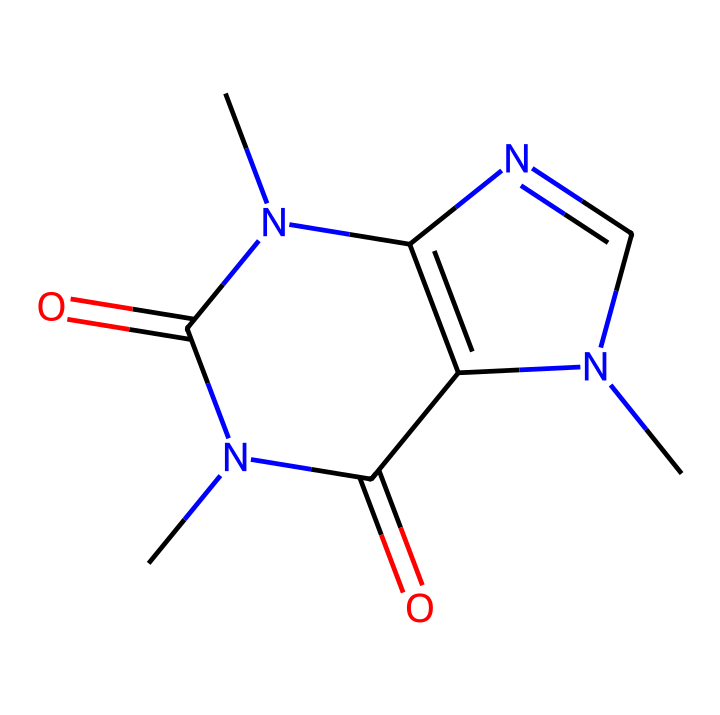What is the molecular formula of caffeine? To determine the molecular formula, we analyze the chemical structure. The SMILES representation indicates there are 8 carbons, 10 hydrogens, 4 nitrogens, and 2 oxygens. By counting, we find the formula is C8H10N4O2.
Answer: C8H10N4O2 How many nitrogen atoms are present in this compound? By inspecting the SMILES representation, we can count the nitrogen atoms. There are 4 nitrogen atoms indicated in the structure.
Answer: 4 What type of isomerism is exhibited by caffeine? Geometric isomerism occurs due to the restricted rotation around the carbon-nitrogen bonds. Caffeine can exist in cis and trans forms regarding the positions of substituents.
Answer: Geometric isomerism What is the main functional group in caffeine? The presence of the carbonyl group (C=O) in the structure identifies this compound as containing two amide functional groups, which are characteristic of caffeine.
Answer: amide How many rings does the caffeine structure contain? Analyzing the structure indicated by the SMILES, we find that caffeine has two fused rings at the center of the molecule.
Answer: 2 What are the possible configurations for the geometric isomers of caffeine? Geometric isomers result from different spatial arrangements of the molecule due to restricted rotation around certain bonds. Caffeine could have cis and trans configurations at the double bonds involving the nitrogen atoms.
Answer: cis and trans 